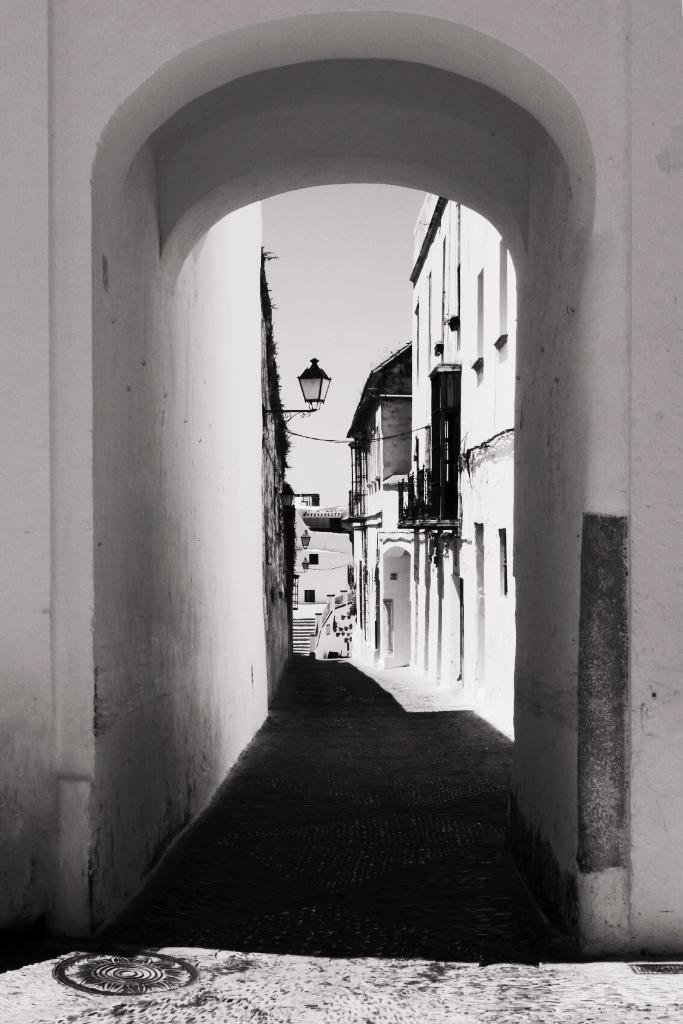What type of structures can be seen in the image? There are buildings in the image. What architectural feature is present in the image? There is an arch in the image. What can be found attached to the walls of the buildings? Objects are attached to the walls of the buildings. What part of the natural environment is visible in the image? The ground and the sky are visible in the image. What type of representative is standing near the arch in the image? There is no representative present in the image; it only features buildings, an arch, and objects attached to the walls. How does the knee of the building affect its structural integrity in the image? There is no mention of a knee in the image, as it refers to a part of the human body and not a feature of a building. 